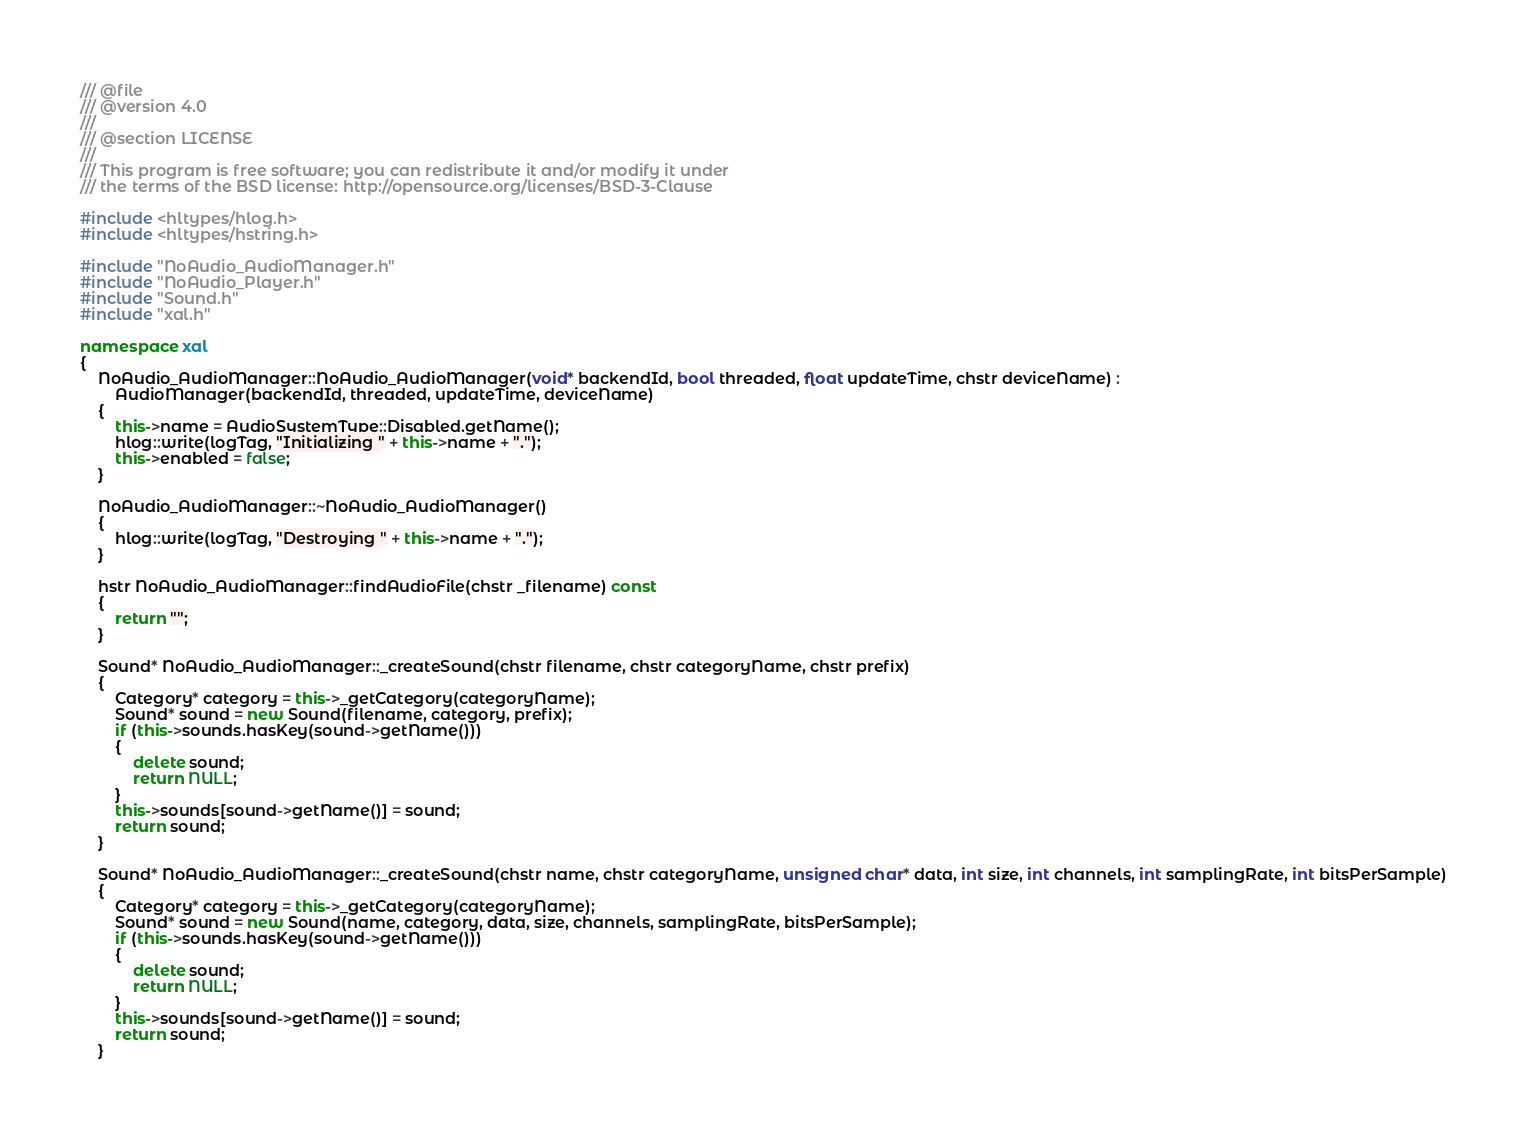Convert code to text. <code><loc_0><loc_0><loc_500><loc_500><_C++_>/// @file
/// @version 4.0
/// 
/// @section LICENSE
/// 
/// This program is free software; you can redistribute it and/or modify it under
/// the terms of the BSD license: http://opensource.org/licenses/BSD-3-Clause

#include <hltypes/hlog.h>
#include <hltypes/hstring.h>

#include "NoAudio_AudioManager.h"
#include "NoAudio_Player.h"
#include "Sound.h"
#include "xal.h"

namespace xal
{
	NoAudio_AudioManager::NoAudio_AudioManager(void* backendId, bool threaded, float updateTime, chstr deviceName) :
		AudioManager(backendId, threaded, updateTime, deviceName)
	{
		this->name = AudioSystemType::Disabled.getName();
		hlog::write(logTag, "Initializing " + this->name + ".");
		this->enabled = false;
	}

	NoAudio_AudioManager::~NoAudio_AudioManager()
	{
		hlog::write(logTag, "Destroying " + this->name + ".");
	}
	
	hstr NoAudio_AudioManager::findAudioFile(chstr _filename) const
	{
		return "";
	}
	
	Sound* NoAudio_AudioManager::_createSound(chstr filename, chstr categoryName, chstr prefix)
	{
		Category* category = this->_getCategory(categoryName);
		Sound* sound = new Sound(filename, category, prefix);
		if (this->sounds.hasKey(sound->getName()))
		{
			delete sound;
			return NULL;
		}
		this->sounds[sound->getName()] = sound;
		return sound;
	}

	Sound* NoAudio_AudioManager::_createSound(chstr name, chstr categoryName, unsigned char* data, int size, int channels, int samplingRate, int bitsPerSample)
	{
		Category* category = this->_getCategory(categoryName);
		Sound* sound = new Sound(name, category, data, size, channels, samplingRate, bitsPerSample);
		if (this->sounds.hasKey(sound->getName()))
		{
			delete sound;
			return NULL;
		}
		this->sounds[sound->getName()] = sound;
		return sound;
	}
</code> 